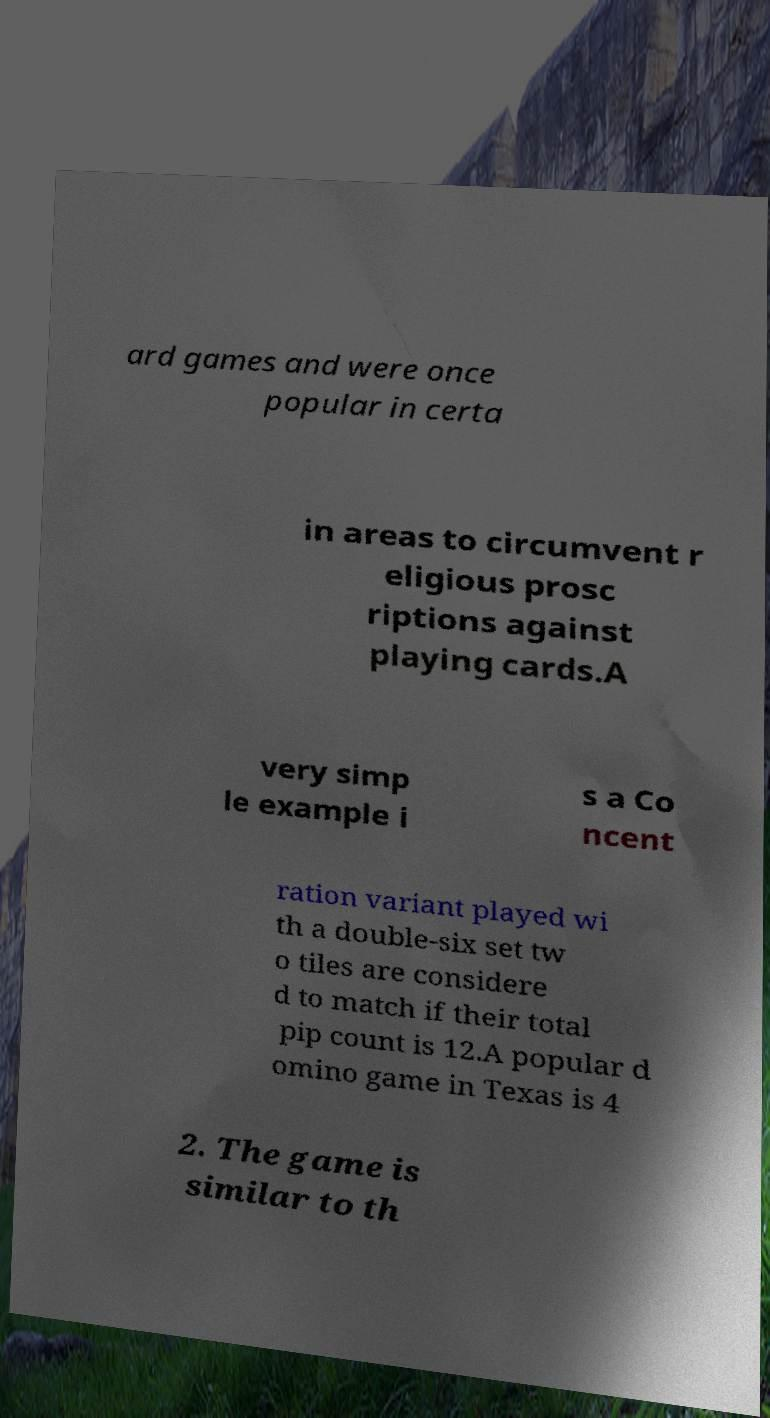Please identify and transcribe the text found in this image. ard games and were once popular in certa in areas to circumvent r eligious prosc riptions against playing cards.A very simp le example i s a Co ncent ration variant played wi th a double-six set tw o tiles are considere d to match if their total pip count is 12.A popular d omino game in Texas is 4 2. The game is similar to th 